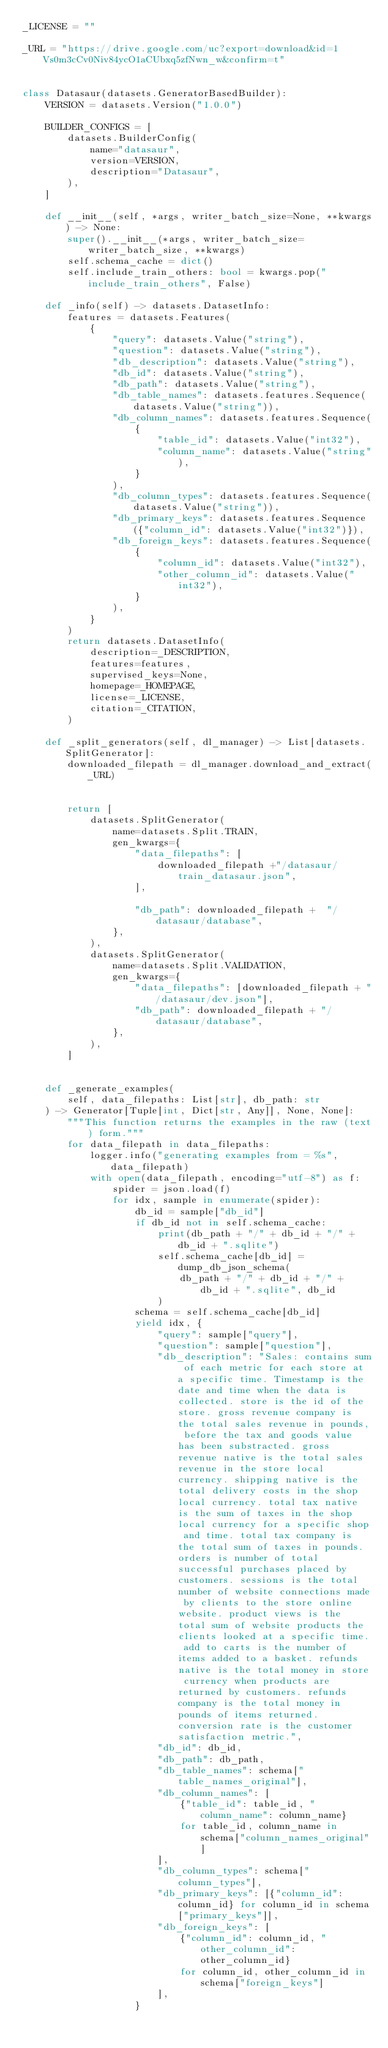<code> <loc_0><loc_0><loc_500><loc_500><_Python_>_LICENSE = ""

_URL = "https://drive.google.com/uc?export=download&id=1Vs0m3cCv0Niv84ycO1aCUbxq5zfNwn_w&confirm=t"


class Datasaur(datasets.GeneratorBasedBuilder):
    VERSION = datasets.Version("1.0.0")

    BUILDER_CONFIGS = [
        datasets.BuilderConfig(
            name="datasaur",
            version=VERSION,
            description="Datasaur",
        ),
    ]

    def __init__(self, *args, writer_batch_size=None, **kwargs) -> None:
        super().__init__(*args, writer_batch_size=writer_batch_size, **kwargs)
        self.schema_cache = dict()
        self.include_train_others: bool = kwargs.pop("include_train_others", False)

    def _info(self) -> datasets.DatasetInfo:
        features = datasets.Features(
            {
                "query": datasets.Value("string"),
                "question": datasets.Value("string"),
                "db_description": datasets.Value("string"),    
                "db_id": datasets.Value("string"),
                "db_path": datasets.Value("string"),
                "db_table_names": datasets.features.Sequence(datasets.Value("string")),
                "db_column_names": datasets.features.Sequence(
                    {
                        "table_id": datasets.Value("int32"),
                        "column_name": datasets.Value("string"),
                    }
                ),
                "db_column_types": datasets.features.Sequence(datasets.Value("string")),
                "db_primary_keys": datasets.features.Sequence({"column_id": datasets.Value("int32")}),
                "db_foreign_keys": datasets.features.Sequence(
                    {
                        "column_id": datasets.Value("int32"),
                        "other_column_id": datasets.Value("int32"),
                    }
                ),
            }
        )
        return datasets.DatasetInfo(
            description=_DESCRIPTION,
            features=features,
            supervised_keys=None,
            homepage=_HOMEPAGE,
            license=_LICENSE,
            citation=_CITATION,
        )

    def _split_generators(self, dl_manager) -> List[datasets.SplitGenerator]:
        downloaded_filepath = dl_manager.download_and_extract(_URL)


        return [
            datasets.SplitGenerator(
                name=datasets.Split.TRAIN,
                gen_kwargs={
                    "data_filepaths": [
                        downloaded_filepath +"/datasaur/train_datasaur.json",
                    ],
                    
                    "db_path": downloaded_filepath +  "/datasaur/database",
                },
            ),
            datasets.SplitGenerator(
                name=datasets.Split.VALIDATION,
                gen_kwargs={
                    "data_filepaths": [downloaded_filepath + "/datasaur/dev.json"],
                    "db_path": downloaded_filepath + "/datasaur/database",
                },
            ),
        ]


    def _generate_examples(
        self, data_filepaths: List[str], db_path: str
    ) -> Generator[Tuple[int, Dict[str, Any]], None, None]:
        """This function returns the examples in the raw (text) form."""
        for data_filepath in data_filepaths:
            logger.info("generating examples from = %s", data_filepath)
            with open(data_filepath, encoding="utf-8") as f:
                spider = json.load(f)
                for idx, sample in enumerate(spider):
                    db_id = sample["db_id"]
                    if db_id not in self.schema_cache:
                        print(db_path + "/" + db_id + "/" + db_id + ".sqlite")
                        self.schema_cache[db_id] = dump_db_json_schema(
                            db_path + "/" + db_id + "/" + db_id + ".sqlite", db_id
                        )
                    schema = self.schema_cache[db_id]
                    yield idx, {
                        "query": sample["query"],
                        "question": sample["question"],
                        "db_description": "Sales: contains sum of each metric for each store at a specific time. Timestamp is the date and time when the data is collected. store is the id of the store. gross revenue company is the total sales revenue in pounds, before the tax and goods value has been substracted. gross revenue native is the total sales revenue in the store local currency. shipping native is the total delivery costs in the shop local currency. total tax native is the sum of taxes in the shop local currency for a specific shop and time. total tax company is the total sum of taxes in pounds. orders is number of total successful purchases placed by customers. sessions is the total number of website connections made by clients to the store online website. product views is the total sum of website products the clients looked at a specific time. add to carts is the number of items added to a basket. refunds native is the total money in store currency when products are returned by customers. refunds company is the total money in pounds of items returned. conversion rate is the customer satisfaction metric.",
                        "db_id": db_id,
                        "db_path": db_path,
                        "db_table_names": schema["table_names_original"],
                        "db_column_names": [
                            {"table_id": table_id, "column_name": column_name}
                            for table_id, column_name in schema["column_names_original"]
                        ],
                        "db_column_types": schema["column_types"],
                        "db_primary_keys": [{"column_id": column_id} for column_id in schema["primary_keys"]],
                        "db_foreign_keys": [
                            {"column_id": column_id, "other_column_id": other_column_id}
                            for column_id, other_column_id in schema["foreign_keys"]
                        ],
                    }
</code> 